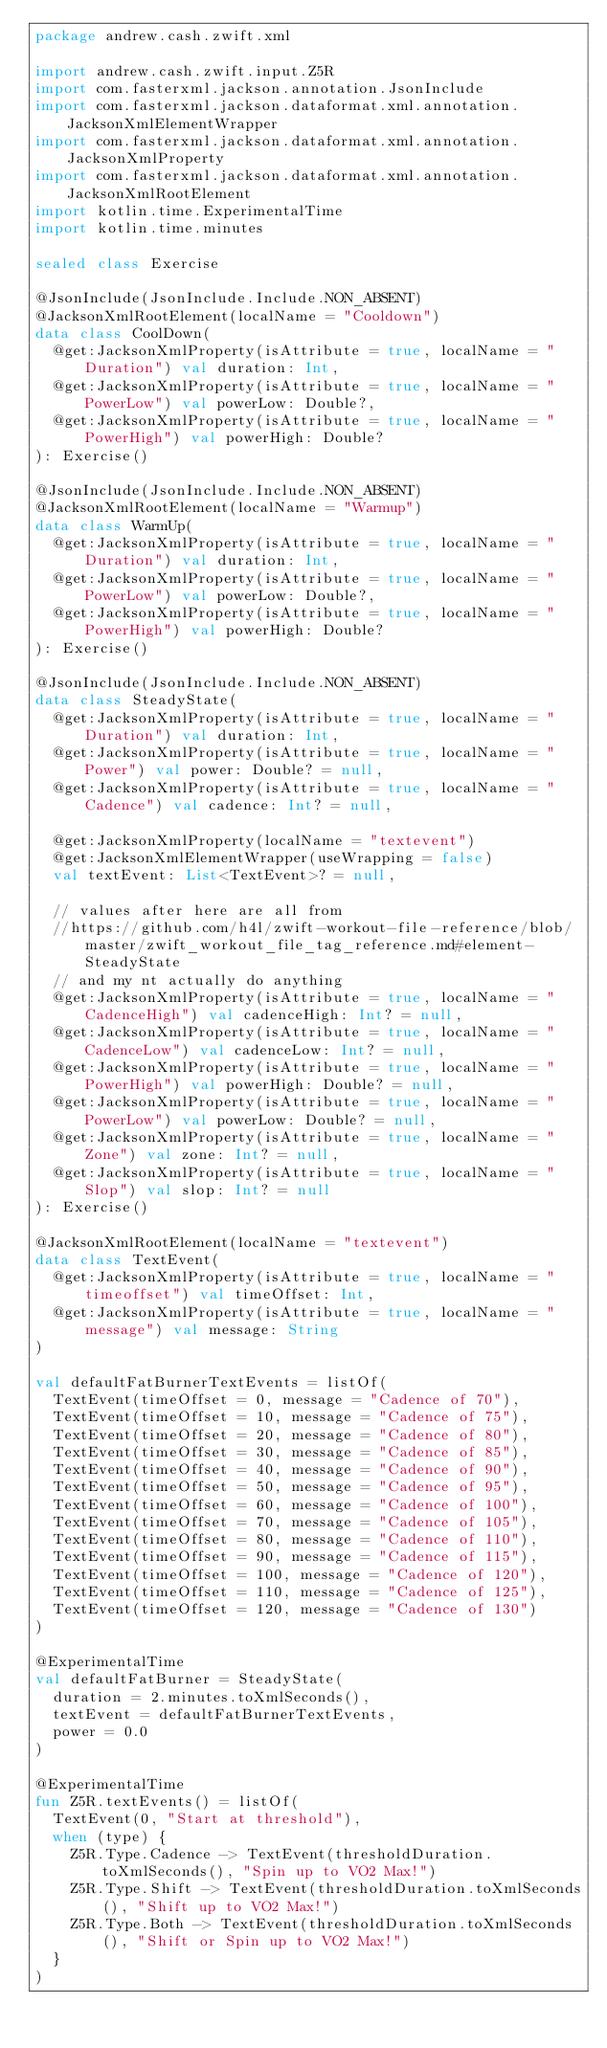Convert code to text. <code><loc_0><loc_0><loc_500><loc_500><_Kotlin_>package andrew.cash.zwift.xml

import andrew.cash.zwift.input.Z5R
import com.fasterxml.jackson.annotation.JsonInclude
import com.fasterxml.jackson.dataformat.xml.annotation.JacksonXmlElementWrapper
import com.fasterxml.jackson.dataformat.xml.annotation.JacksonXmlProperty
import com.fasterxml.jackson.dataformat.xml.annotation.JacksonXmlRootElement
import kotlin.time.ExperimentalTime
import kotlin.time.minutes

sealed class Exercise

@JsonInclude(JsonInclude.Include.NON_ABSENT)
@JacksonXmlRootElement(localName = "Cooldown")
data class CoolDown(
  @get:JacksonXmlProperty(isAttribute = true, localName = "Duration") val duration: Int,
  @get:JacksonXmlProperty(isAttribute = true, localName = "PowerLow") val powerLow: Double?,
  @get:JacksonXmlProperty(isAttribute = true, localName = "PowerHigh") val powerHigh: Double?
): Exercise()

@JsonInclude(JsonInclude.Include.NON_ABSENT)
@JacksonXmlRootElement(localName = "Warmup")
data class WarmUp(
  @get:JacksonXmlProperty(isAttribute = true, localName = "Duration") val duration: Int,
  @get:JacksonXmlProperty(isAttribute = true, localName = "PowerLow") val powerLow: Double?,
  @get:JacksonXmlProperty(isAttribute = true, localName = "PowerHigh") val powerHigh: Double?
): Exercise()

@JsonInclude(JsonInclude.Include.NON_ABSENT)
data class SteadyState(
  @get:JacksonXmlProperty(isAttribute = true, localName = "Duration") val duration: Int,
  @get:JacksonXmlProperty(isAttribute = true, localName = "Power") val power: Double? = null,
  @get:JacksonXmlProperty(isAttribute = true, localName = "Cadence") val cadence: Int? = null,

  @get:JacksonXmlProperty(localName = "textevent")
  @get:JacksonXmlElementWrapper(useWrapping = false)
  val textEvent: List<TextEvent>? = null,

  // values after here are all from
  //https://github.com/h4l/zwift-workout-file-reference/blob/master/zwift_workout_file_tag_reference.md#element-SteadyState
  // and my nt actually do anything
  @get:JacksonXmlProperty(isAttribute = true, localName = "CadenceHigh") val cadenceHigh: Int? = null,
  @get:JacksonXmlProperty(isAttribute = true, localName = "CadenceLow") val cadenceLow: Int? = null,
  @get:JacksonXmlProperty(isAttribute = true, localName = "PowerHigh") val powerHigh: Double? = null,
  @get:JacksonXmlProperty(isAttribute = true, localName = "PowerLow") val powerLow: Double? = null,
  @get:JacksonXmlProperty(isAttribute = true, localName = "Zone") val zone: Int? = null,
  @get:JacksonXmlProperty(isAttribute = true, localName = "Slop") val slop: Int? = null
): Exercise()

@JacksonXmlRootElement(localName = "textevent")
data class TextEvent(
  @get:JacksonXmlProperty(isAttribute = true, localName = "timeoffset") val timeOffset: Int,
  @get:JacksonXmlProperty(isAttribute = true, localName = "message") val message: String
)

val defaultFatBurnerTextEvents = listOf(
  TextEvent(timeOffset = 0, message = "Cadence of 70"),
  TextEvent(timeOffset = 10, message = "Cadence of 75"),
  TextEvent(timeOffset = 20, message = "Cadence of 80"),
  TextEvent(timeOffset = 30, message = "Cadence of 85"),
  TextEvent(timeOffset = 40, message = "Cadence of 90"),
  TextEvent(timeOffset = 50, message = "Cadence of 95"),
  TextEvent(timeOffset = 60, message = "Cadence of 100"),
  TextEvent(timeOffset = 70, message = "Cadence of 105"),
  TextEvent(timeOffset = 80, message = "Cadence of 110"),
  TextEvent(timeOffset = 90, message = "Cadence of 115"),
  TextEvent(timeOffset = 100, message = "Cadence of 120"),
  TextEvent(timeOffset = 110, message = "Cadence of 125"),
  TextEvent(timeOffset = 120, message = "Cadence of 130")
)

@ExperimentalTime
val defaultFatBurner = SteadyState(
  duration = 2.minutes.toXmlSeconds(),
  textEvent = defaultFatBurnerTextEvents,
  power = 0.0
)

@ExperimentalTime
fun Z5R.textEvents() = listOf(
  TextEvent(0, "Start at threshold"),
  when (type) {
    Z5R.Type.Cadence -> TextEvent(thresholdDuration.toXmlSeconds(), "Spin up to VO2 Max!")
    Z5R.Type.Shift -> TextEvent(thresholdDuration.toXmlSeconds(), "Shift up to VO2 Max!")
    Z5R.Type.Both -> TextEvent(thresholdDuration.toXmlSeconds(), "Shift or Spin up to VO2 Max!")
  }
)
</code> 